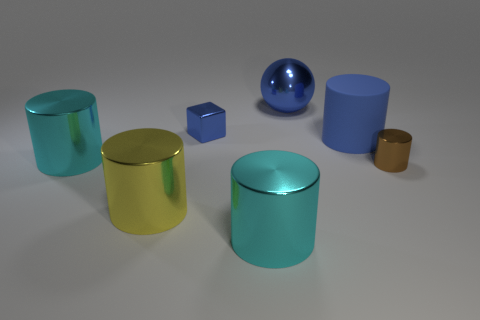There is a cyan cylinder that is right of the big metal cylinder to the left of the big yellow thing; are there any large metal spheres that are in front of it?
Your response must be concise. No. What is the material of the other yellow object that is the same shape as the big rubber object?
Your answer should be very brief. Metal. The tiny thing behind the small brown cylinder is what color?
Provide a short and direct response. Blue. The ball has what size?
Offer a very short reply. Large. Is the size of the brown metal cylinder the same as the cyan metallic cylinder left of the big yellow shiny object?
Offer a very short reply. No. What color is the big cylinder that is to the right of the large blue thing that is left of the blue thing that is in front of the small shiny cube?
Provide a succinct answer. Blue. Do the cylinder right of the matte thing and the blue ball have the same material?
Give a very brief answer. Yes. How many other objects are there of the same material as the large yellow cylinder?
Your answer should be very brief. 5. What material is the object that is the same size as the cube?
Keep it short and to the point. Metal. Does the blue object on the left side of the big blue shiny thing have the same shape as the cyan thing that is behind the small cylinder?
Offer a terse response. No. 